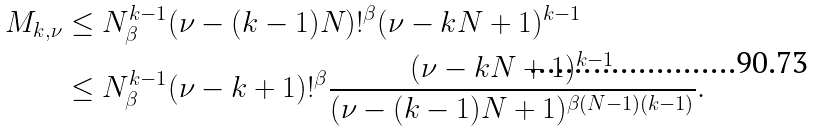<formula> <loc_0><loc_0><loc_500><loc_500>M _ { k , \nu } & \leq N _ { \beta } ^ { k - 1 } ( \nu - ( k - 1 ) N ) ! ^ { \beta } ( \nu - k N + 1 ) ^ { k - 1 } \\ & \leq N _ { \beta } ^ { k - 1 } ( \nu - k + 1 ) ! ^ { \beta } \frac { ( \nu - k N + 1 ) ^ { k - 1 } } { ( \nu - ( k - 1 ) N + 1 ) ^ { \beta ( N - 1 ) ( k - 1 ) } } .</formula> 